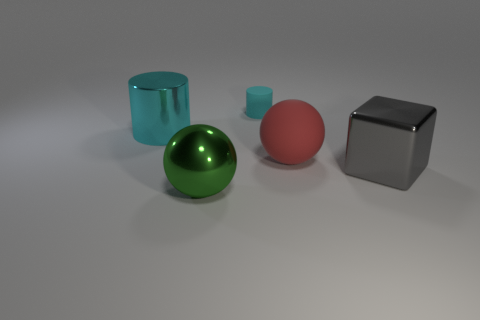There is a large shiny thing right of the small rubber thing; what is its shape?
Provide a short and direct response. Cube. Are there any big rubber things of the same color as the big cylinder?
Offer a very short reply. No. Do the sphere that is to the left of the tiny cyan matte object and the rubber thing that is behind the big red ball have the same size?
Provide a short and direct response. No. Are there more large red rubber objects in front of the cyan rubber cylinder than red objects that are behind the large red rubber object?
Give a very brief answer. Yes. Is there a small red cylinder made of the same material as the large cylinder?
Keep it short and to the point. No. Is the big metallic block the same color as the metallic sphere?
Make the answer very short. No. There is a big thing that is to the right of the green metallic ball and left of the gray object; what material is it made of?
Offer a terse response. Rubber. The big block is what color?
Your answer should be very brief. Gray. How many other green shiny objects have the same shape as the green metal thing?
Ensure brevity in your answer.  0. Is the material of the tiny cylinder that is behind the large cyan object the same as the ball right of the tiny rubber cylinder?
Ensure brevity in your answer.  Yes. 